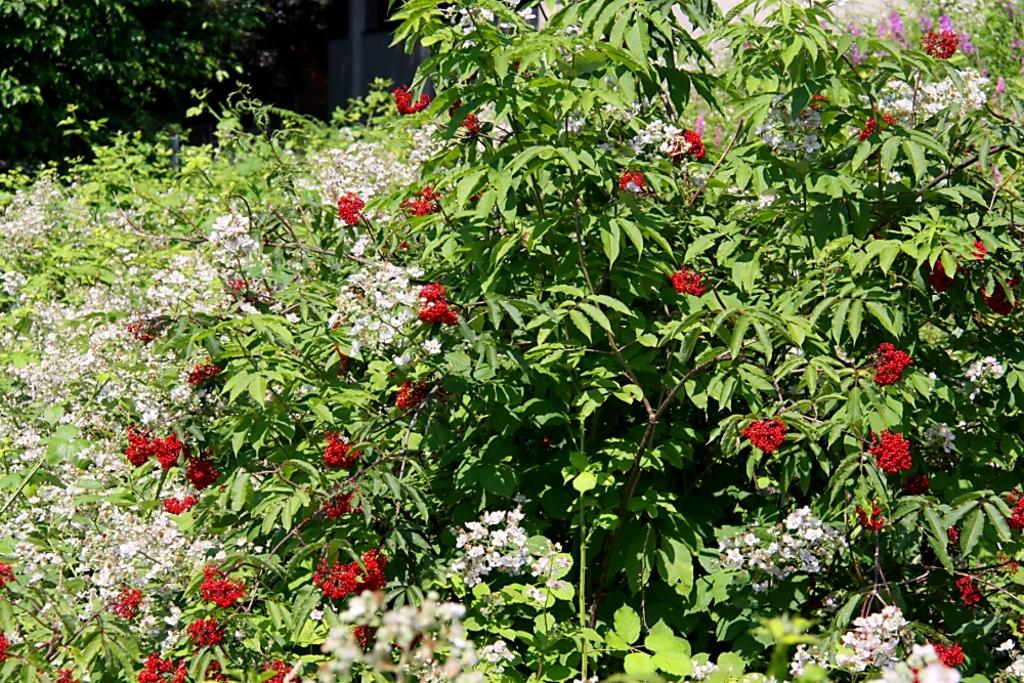What type of plants can be seen in the image? There are plants with flowers in the image. What color are the leaves of the plants? The plants have green leaves. What can be seen in the background of the image? There are branches of a tree with green leaves and a wall visible in the background. What type of map can be seen on the wall in the image? There is no map present on the wall in the image; only a wall is visible in the background. 